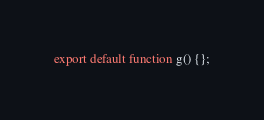<code> <loc_0><loc_0><loc_500><loc_500><_JavaScript_>export default function g() {};
</code> 